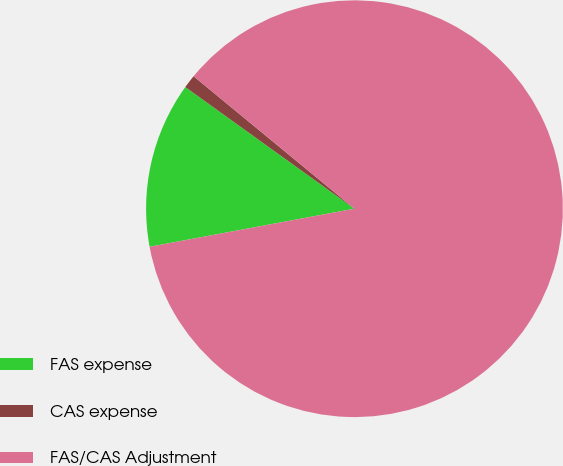Convert chart to OTSL. <chart><loc_0><loc_0><loc_500><loc_500><pie_chart><fcel>FAS expense<fcel>CAS expense<fcel>FAS/CAS Adjustment<nl><fcel>12.85%<fcel>1.04%<fcel>86.11%<nl></chart> 